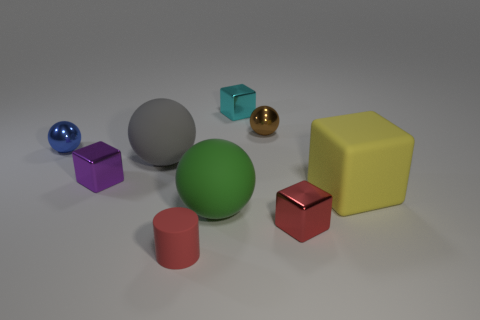Add 1 red metal objects. How many objects exist? 10 Subtract all green spheres. How many spheres are left? 3 Add 5 tiny blue objects. How many tiny blue objects are left? 6 Add 2 big brown matte objects. How many big brown matte objects exist? 2 Subtract all metallic blocks. How many blocks are left? 1 Subtract 0 purple cylinders. How many objects are left? 9 Subtract all cylinders. How many objects are left? 8 Subtract 3 blocks. How many blocks are left? 1 Subtract all yellow spheres. Subtract all red cubes. How many spheres are left? 4 Subtract all gray cylinders. How many blue spheres are left? 1 